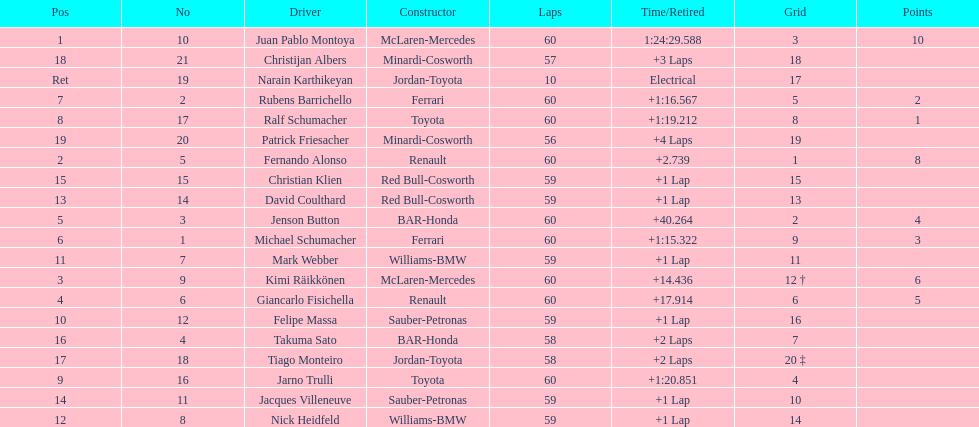Which driver in the top 8, drives a mclaran-mercedes but is not in first place? Kimi Räikkönen. Help me parse the entirety of this table. {'header': ['Pos', 'No', 'Driver', 'Constructor', 'Laps', 'Time/Retired', 'Grid', 'Points'], 'rows': [['1', '10', 'Juan Pablo Montoya', 'McLaren-Mercedes', '60', '1:24:29.588', '3', '10'], ['18', '21', 'Christijan Albers', 'Minardi-Cosworth', '57', '+3 Laps', '18', ''], ['Ret', '19', 'Narain Karthikeyan', 'Jordan-Toyota', '10', 'Electrical', '17', ''], ['7', '2', 'Rubens Barrichello', 'Ferrari', '60', '+1:16.567', '5', '2'], ['8', '17', 'Ralf Schumacher', 'Toyota', '60', '+1:19.212', '8', '1'], ['19', '20', 'Patrick Friesacher', 'Minardi-Cosworth', '56', '+4 Laps', '19', ''], ['2', '5', 'Fernando Alonso', 'Renault', '60', '+2.739', '1', '8'], ['15', '15', 'Christian Klien', 'Red Bull-Cosworth', '59', '+1 Lap', '15', ''], ['13', '14', 'David Coulthard', 'Red Bull-Cosworth', '59', '+1 Lap', '13', ''], ['5', '3', 'Jenson Button', 'BAR-Honda', '60', '+40.264', '2', '4'], ['6', '1', 'Michael Schumacher', 'Ferrari', '60', '+1:15.322', '9', '3'], ['11', '7', 'Mark Webber', 'Williams-BMW', '59', '+1 Lap', '11', ''], ['3', '9', 'Kimi Räikkönen', 'McLaren-Mercedes', '60', '+14.436', '12 †', '6'], ['4', '6', 'Giancarlo Fisichella', 'Renault', '60', '+17.914', '6', '5'], ['10', '12', 'Felipe Massa', 'Sauber-Petronas', '59', '+1 Lap', '16', ''], ['16', '4', 'Takuma Sato', 'BAR-Honda', '58', '+2 Laps', '7', ''], ['17', '18', 'Tiago Monteiro', 'Jordan-Toyota', '58', '+2 Laps', '20 ‡', ''], ['9', '16', 'Jarno Trulli', 'Toyota', '60', '+1:20.851', '4', ''], ['14', '11', 'Jacques Villeneuve', 'Sauber-Petronas', '59', '+1 Lap', '10', ''], ['12', '8', 'Nick Heidfeld', 'Williams-BMW', '59', '+1 Lap', '14', '']]} 